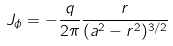<formula> <loc_0><loc_0><loc_500><loc_500>J _ { \phi } = - \frac { q } { 2 \pi } \frac { r } { ( a ^ { 2 } - r ^ { 2 } ) ^ { 3 / 2 } }</formula> 